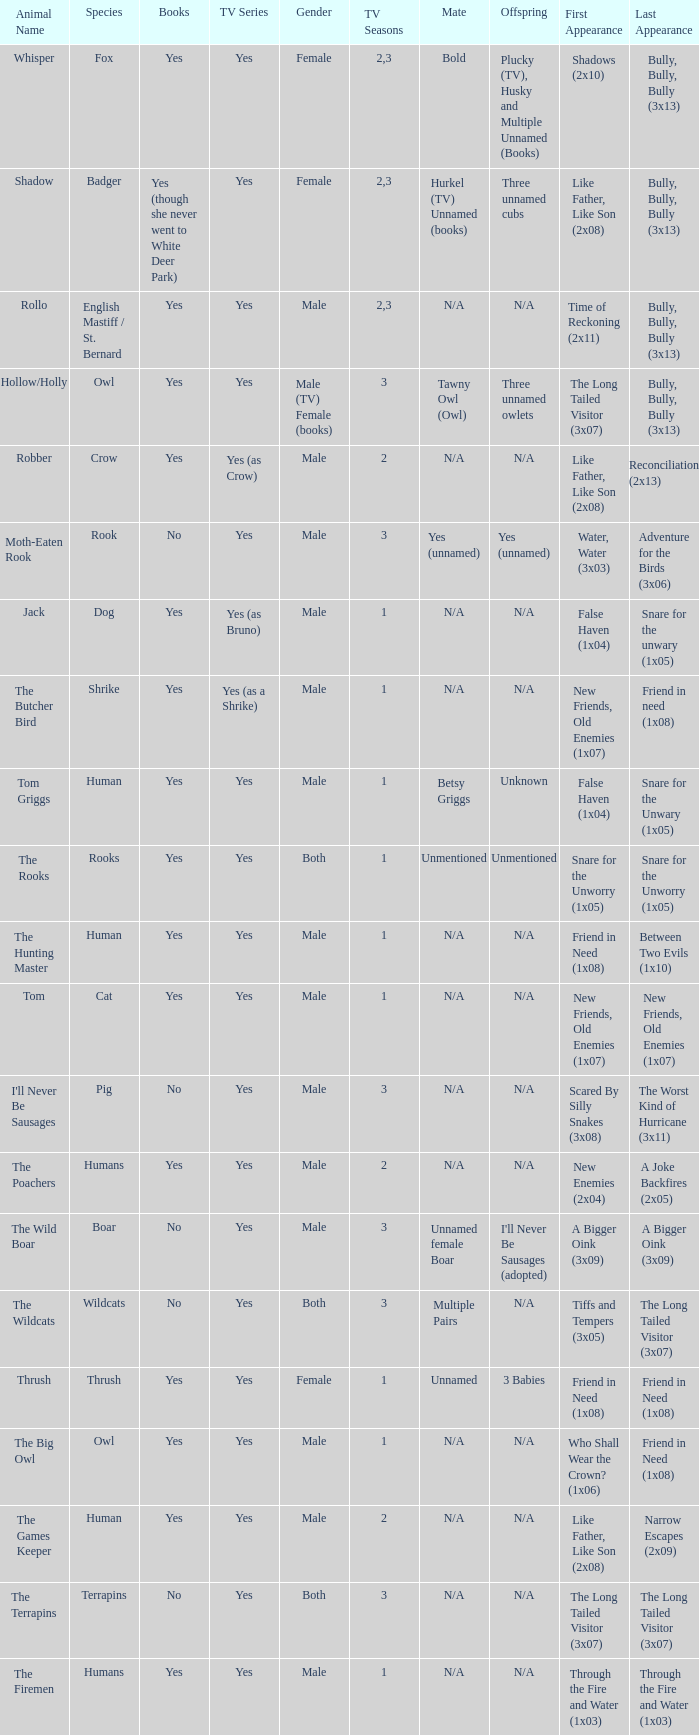What is the shortest season of a tv series that features a human character and has a positive response? 1.0. 